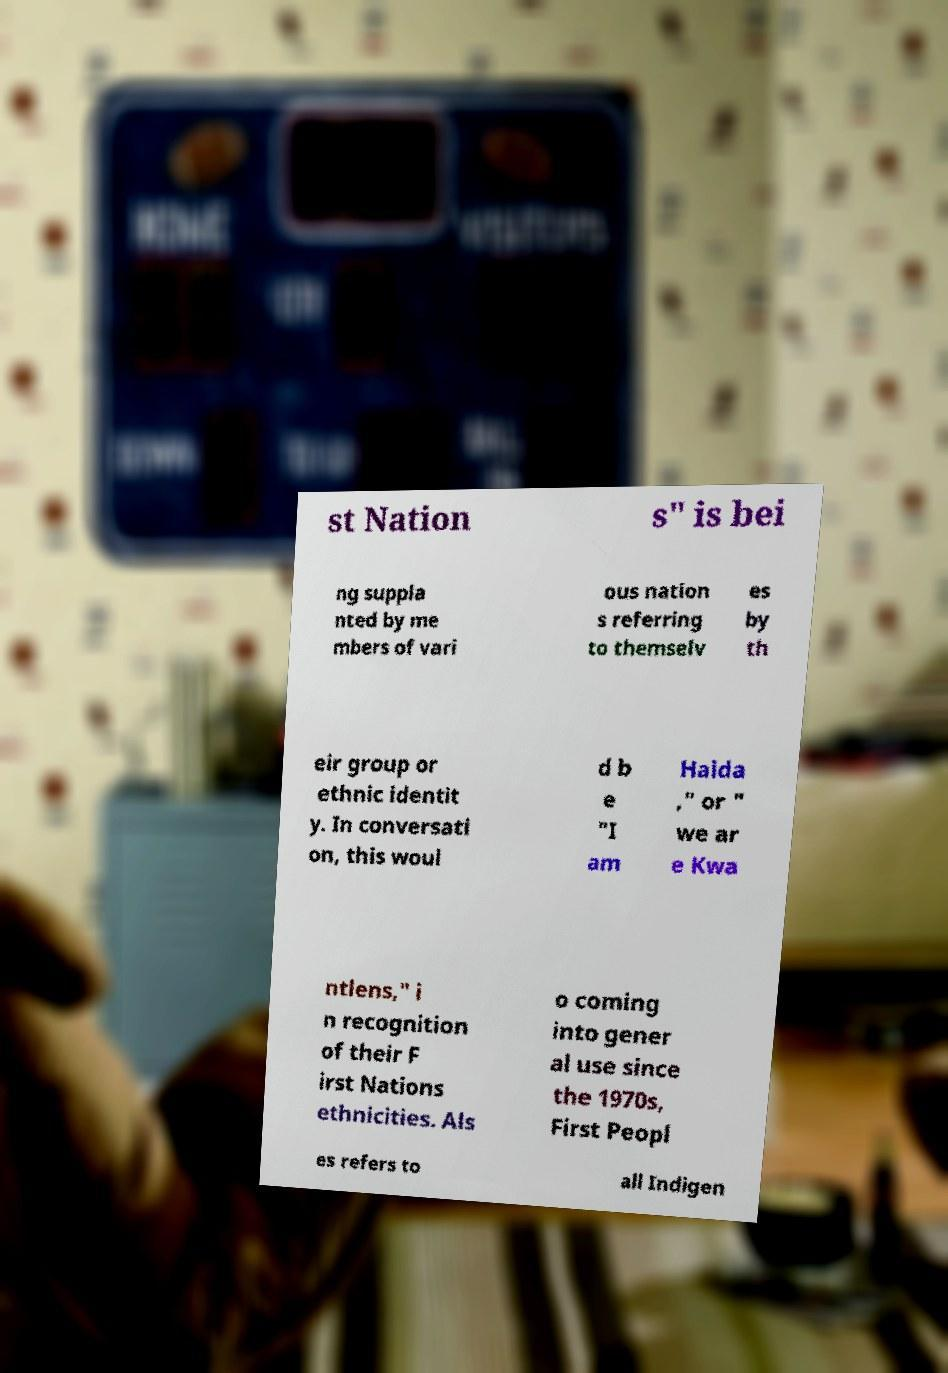What messages or text are displayed in this image? I need them in a readable, typed format. st Nation s" is bei ng suppla nted by me mbers of vari ous nation s referring to themselv es by th eir group or ethnic identit y. In conversati on, this woul d b e "I am Haida ," or " we ar e Kwa ntlens," i n recognition of their F irst Nations ethnicities. Als o coming into gener al use since the 1970s, First Peopl es refers to all Indigen 